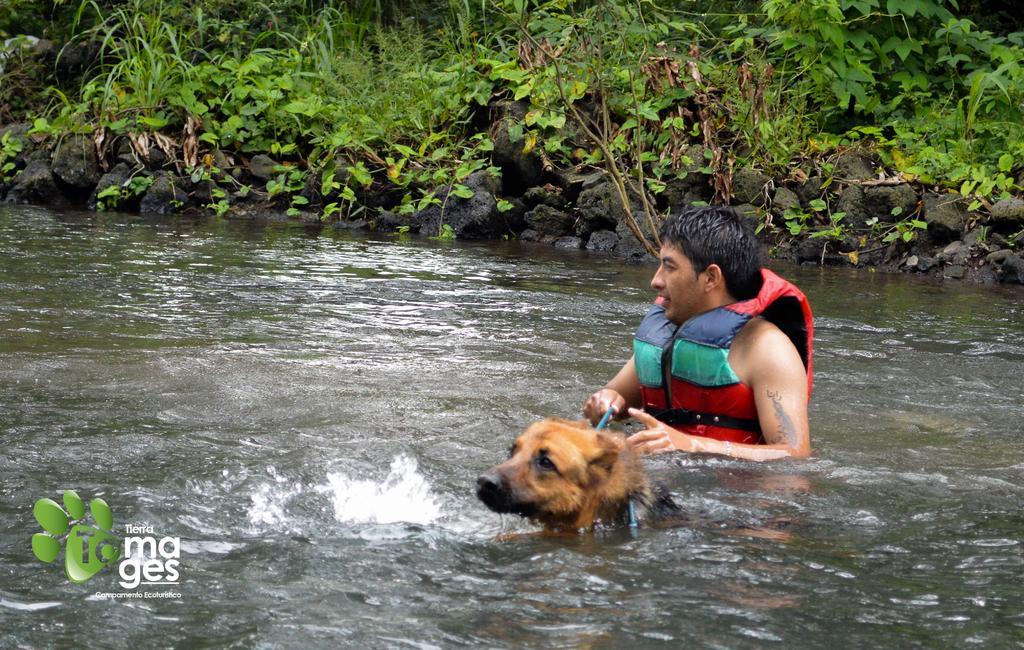Please provide a concise description of this image. In this picture there is a person in water is wearing a live jacket and holding a belt which is attached to the dog in front of him and there are few plants in the background and there is something written in the left bottom corner. 